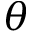Convert formula to latex. <formula><loc_0><loc_0><loc_500><loc_500>\theta</formula> 